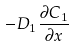<formula> <loc_0><loc_0><loc_500><loc_500>- D _ { 1 } \frac { \partial C _ { 1 } } { \partial x }</formula> 